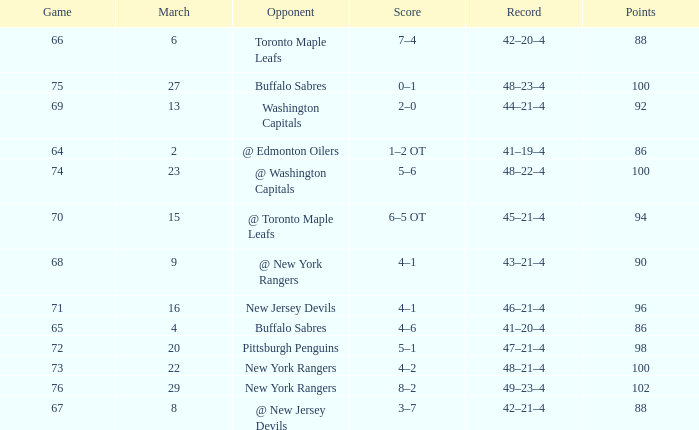Which Score has a March larger than 15, and Points larger than 96, and a Game smaller than 76, and an Opponent of @ washington capitals? 5–6. 